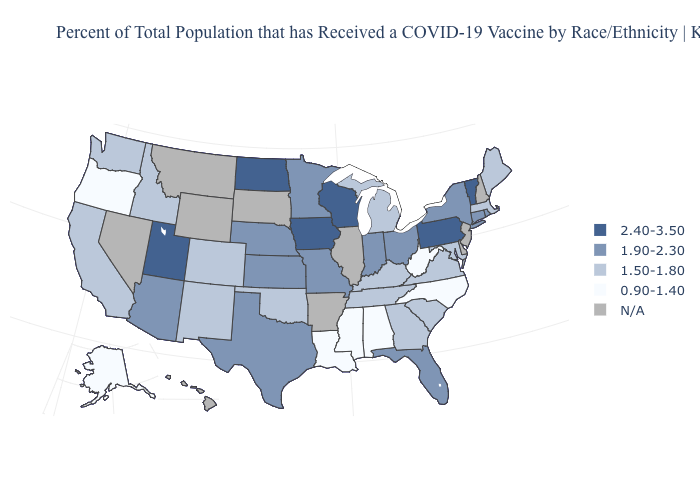Name the states that have a value in the range 1.50-1.80?
Quick response, please. California, Colorado, Georgia, Idaho, Kentucky, Maine, Maryland, Massachusetts, Michigan, New Mexico, Oklahoma, South Carolina, Tennessee, Virginia, Washington. Is the legend a continuous bar?
Concise answer only. No. Does Michigan have the highest value in the USA?
Answer briefly. No. Does the first symbol in the legend represent the smallest category?
Be succinct. No. Among the states that border North Carolina , which have the highest value?
Concise answer only. Georgia, South Carolina, Tennessee, Virginia. How many symbols are there in the legend?
Be succinct. 5. What is the value of New York?
Concise answer only. 1.90-2.30. Which states have the lowest value in the West?
Be succinct. Alaska, Oregon. What is the value of Wyoming?
Answer briefly. N/A. What is the lowest value in states that border Texas?
Answer briefly. 0.90-1.40. Does Indiana have the lowest value in the USA?
Give a very brief answer. No. Does Florida have the lowest value in the South?
Quick response, please. No. Does the first symbol in the legend represent the smallest category?
Write a very short answer. No. What is the value of Mississippi?
Concise answer only. 0.90-1.40. Does Michigan have the highest value in the USA?
Concise answer only. No. 